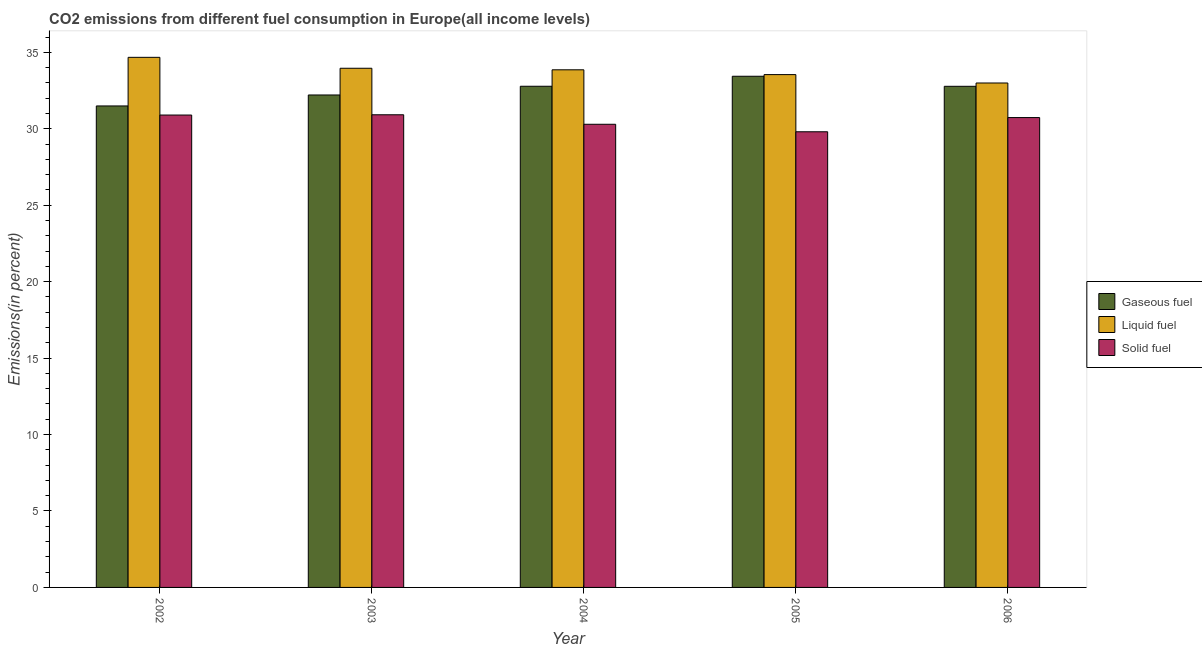How many bars are there on the 2nd tick from the left?
Provide a short and direct response. 3. What is the label of the 5th group of bars from the left?
Ensure brevity in your answer.  2006. In how many cases, is the number of bars for a given year not equal to the number of legend labels?
Your response must be concise. 0. What is the percentage of liquid fuel emission in 2003?
Your answer should be compact. 33.96. Across all years, what is the maximum percentage of solid fuel emission?
Offer a very short reply. 30.92. Across all years, what is the minimum percentage of liquid fuel emission?
Provide a short and direct response. 33. In which year was the percentage of liquid fuel emission maximum?
Your response must be concise. 2002. In which year was the percentage of gaseous fuel emission minimum?
Make the answer very short. 2002. What is the total percentage of solid fuel emission in the graph?
Ensure brevity in your answer.  152.65. What is the difference between the percentage of liquid fuel emission in 2002 and that in 2003?
Offer a terse response. 0.71. What is the difference between the percentage of liquid fuel emission in 2003 and the percentage of gaseous fuel emission in 2004?
Offer a terse response. 0.1. What is the average percentage of liquid fuel emission per year?
Provide a succinct answer. 33.81. In how many years, is the percentage of gaseous fuel emission greater than 31 %?
Offer a terse response. 5. What is the ratio of the percentage of gaseous fuel emission in 2002 to that in 2005?
Offer a terse response. 0.94. What is the difference between the highest and the second highest percentage of liquid fuel emission?
Your response must be concise. 0.71. What is the difference between the highest and the lowest percentage of gaseous fuel emission?
Ensure brevity in your answer.  1.94. Is the sum of the percentage of solid fuel emission in 2003 and 2006 greater than the maximum percentage of gaseous fuel emission across all years?
Keep it short and to the point. Yes. What does the 3rd bar from the left in 2005 represents?
Your response must be concise. Solid fuel. What does the 1st bar from the right in 2004 represents?
Ensure brevity in your answer.  Solid fuel. Are all the bars in the graph horizontal?
Ensure brevity in your answer.  No. What is the difference between two consecutive major ticks on the Y-axis?
Ensure brevity in your answer.  5. Where does the legend appear in the graph?
Offer a terse response. Center right. How are the legend labels stacked?
Offer a very short reply. Vertical. What is the title of the graph?
Give a very brief answer. CO2 emissions from different fuel consumption in Europe(all income levels). What is the label or title of the Y-axis?
Provide a succinct answer. Emissions(in percent). What is the Emissions(in percent) in Gaseous fuel in 2002?
Ensure brevity in your answer.  31.5. What is the Emissions(in percent) of Liquid fuel in 2002?
Keep it short and to the point. 34.68. What is the Emissions(in percent) in Solid fuel in 2002?
Your answer should be very brief. 30.9. What is the Emissions(in percent) in Gaseous fuel in 2003?
Your response must be concise. 32.21. What is the Emissions(in percent) in Liquid fuel in 2003?
Keep it short and to the point. 33.96. What is the Emissions(in percent) in Solid fuel in 2003?
Offer a very short reply. 30.92. What is the Emissions(in percent) in Gaseous fuel in 2004?
Give a very brief answer. 32.78. What is the Emissions(in percent) of Liquid fuel in 2004?
Your answer should be very brief. 33.86. What is the Emissions(in percent) in Solid fuel in 2004?
Offer a terse response. 30.3. What is the Emissions(in percent) in Gaseous fuel in 2005?
Offer a very short reply. 33.44. What is the Emissions(in percent) in Liquid fuel in 2005?
Offer a very short reply. 33.55. What is the Emissions(in percent) of Solid fuel in 2005?
Give a very brief answer. 29.81. What is the Emissions(in percent) in Gaseous fuel in 2006?
Your response must be concise. 32.78. What is the Emissions(in percent) in Liquid fuel in 2006?
Your answer should be compact. 33. What is the Emissions(in percent) of Solid fuel in 2006?
Provide a short and direct response. 30.73. Across all years, what is the maximum Emissions(in percent) of Gaseous fuel?
Offer a very short reply. 33.44. Across all years, what is the maximum Emissions(in percent) in Liquid fuel?
Provide a short and direct response. 34.68. Across all years, what is the maximum Emissions(in percent) of Solid fuel?
Your answer should be very brief. 30.92. Across all years, what is the minimum Emissions(in percent) of Gaseous fuel?
Keep it short and to the point. 31.5. Across all years, what is the minimum Emissions(in percent) in Liquid fuel?
Offer a terse response. 33. Across all years, what is the minimum Emissions(in percent) in Solid fuel?
Offer a very short reply. 29.81. What is the total Emissions(in percent) of Gaseous fuel in the graph?
Give a very brief answer. 162.71. What is the total Emissions(in percent) of Liquid fuel in the graph?
Offer a terse response. 169.04. What is the total Emissions(in percent) of Solid fuel in the graph?
Your answer should be compact. 152.65. What is the difference between the Emissions(in percent) in Gaseous fuel in 2002 and that in 2003?
Give a very brief answer. -0.72. What is the difference between the Emissions(in percent) of Liquid fuel in 2002 and that in 2003?
Give a very brief answer. 0.71. What is the difference between the Emissions(in percent) in Solid fuel in 2002 and that in 2003?
Offer a terse response. -0.02. What is the difference between the Emissions(in percent) of Gaseous fuel in 2002 and that in 2004?
Offer a terse response. -1.29. What is the difference between the Emissions(in percent) of Liquid fuel in 2002 and that in 2004?
Offer a terse response. 0.82. What is the difference between the Emissions(in percent) of Solid fuel in 2002 and that in 2004?
Your answer should be compact. 0.6. What is the difference between the Emissions(in percent) in Gaseous fuel in 2002 and that in 2005?
Make the answer very short. -1.94. What is the difference between the Emissions(in percent) in Liquid fuel in 2002 and that in 2005?
Make the answer very short. 1.13. What is the difference between the Emissions(in percent) of Solid fuel in 2002 and that in 2005?
Ensure brevity in your answer.  1.09. What is the difference between the Emissions(in percent) in Gaseous fuel in 2002 and that in 2006?
Provide a succinct answer. -1.28. What is the difference between the Emissions(in percent) in Liquid fuel in 2002 and that in 2006?
Provide a short and direct response. 1.68. What is the difference between the Emissions(in percent) of Solid fuel in 2002 and that in 2006?
Your answer should be very brief. 0.17. What is the difference between the Emissions(in percent) of Gaseous fuel in 2003 and that in 2004?
Keep it short and to the point. -0.57. What is the difference between the Emissions(in percent) of Liquid fuel in 2003 and that in 2004?
Ensure brevity in your answer.  0.1. What is the difference between the Emissions(in percent) in Solid fuel in 2003 and that in 2004?
Ensure brevity in your answer.  0.62. What is the difference between the Emissions(in percent) in Gaseous fuel in 2003 and that in 2005?
Make the answer very short. -1.22. What is the difference between the Emissions(in percent) in Liquid fuel in 2003 and that in 2005?
Your response must be concise. 0.41. What is the difference between the Emissions(in percent) of Solid fuel in 2003 and that in 2005?
Your answer should be very brief. 1.11. What is the difference between the Emissions(in percent) in Gaseous fuel in 2003 and that in 2006?
Your response must be concise. -0.57. What is the difference between the Emissions(in percent) of Liquid fuel in 2003 and that in 2006?
Give a very brief answer. 0.96. What is the difference between the Emissions(in percent) in Solid fuel in 2003 and that in 2006?
Offer a very short reply. 0.18. What is the difference between the Emissions(in percent) of Gaseous fuel in 2004 and that in 2005?
Ensure brevity in your answer.  -0.65. What is the difference between the Emissions(in percent) in Liquid fuel in 2004 and that in 2005?
Keep it short and to the point. 0.31. What is the difference between the Emissions(in percent) in Solid fuel in 2004 and that in 2005?
Ensure brevity in your answer.  0.49. What is the difference between the Emissions(in percent) in Gaseous fuel in 2004 and that in 2006?
Keep it short and to the point. 0. What is the difference between the Emissions(in percent) in Liquid fuel in 2004 and that in 2006?
Keep it short and to the point. 0.86. What is the difference between the Emissions(in percent) in Solid fuel in 2004 and that in 2006?
Your answer should be compact. -0.44. What is the difference between the Emissions(in percent) in Gaseous fuel in 2005 and that in 2006?
Your answer should be very brief. 0.66. What is the difference between the Emissions(in percent) in Liquid fuel in 2005 and that in 2006?
Your answer should be very brief. 0.55. What is the difference between the Emissions(in percent) in Solid fuel in 2005 and that in 2006?
Provide a succinct answer. -0.93. What is the difference between the Emissions(in percent) in Gaseous fuel in 2002 and the Emissions(in percent) in Liquid fuel in 2003?
Your response must be concise. -2.47. What is the difference between the Emissions(in percent) in Gaseous fuel in 2002 and the Emissions(in percent) in Solid fuel in 2003?
Your answer should be compact. 0.58. What is the difference between the Emissions(in percent) of Liquid fuel in 2002 and the Emissions(in percent) of Solid fuel in 2003?
Provide a succinct answer. 3.76. What is the difference between the Emissions(in percent) of Gaseous fuel in 2002 and the Emissions(in percent) of Liquid fuel in 2004?
Your response must be concise. -2.36. What is the difference between the Emissions(in percent) in Gaseous fuel in 2002 and the Emissions(in percent) in Solid fuel in 2004?
Ensure brevity in your answer.  1.2. What is the difference between the Emissions(in percent) in Liquid fuel in 2002 and the Emissions(in percent) in Solid fuel in 2004?
Offer a very short reply. 4.38. What is the difference between the Emissions(in percent) in Gaseous fuel in 2002 and the Emissions(in percent) in Liquid fuel in 2005?
Ensure brevity in your answer.  -2.05. What is the difference between the Emissions(in percent) of Gaseous fuel in 2002 and the Emissions(in percent) of Solid fuel in 2005?
Offer a terse response. 1.69. What is the difference between the Emissions(in percent) in Liquid fuel in 2002 and the Emissions(in percent) in Solid fuel in 2005?
Keep it short and to the point. 4.87. What is the difference between the Emissions(in percent) in Gaseous fuel in 2002 and the Emissions(in percent) in Liquid fuel in 2006?
Your answer should be very brief. -1.5. What is the difference between the Emissions(in percent) of Gaseous fuel in 2002 and the Emissions(in percent) of Solid fuel in 2006?
Keep it short and to the point. 0.76. What is the difference between the Emissions(in percent) of Liquid fuel in 2002 and the Emissions(in percent) of Solid fuel in 2006?
Your answer should be compact. 3.94. What is the difference between the Emissions(in percent) in Gaseous fuel in 2003 and the Emissions(in percent) in Liquid fuel in 2004?
Offer a terse response. -1.65. What is the difference between the Emissions(in percent) in Gaseous fuel in 2003 and the Emissions(in percent) in Solid fuel in 2004?
Your answer should be very brief. 1.92. What is the difference between the Emissions(in percent) of Liquid fuel in 2003 and the Emissions(in percent) of Solid fuel in 2004?
Make the answer very short. 3.66. What is the difference between the Emissions(in percent) in Gaseous fuel in 2003 and the Emissions(in percent) in Liquid fuel in 2005?
Keep it short and to the point. -1.33. What is the difference between the Emissions(in percent) in Gaseous fuel in 2003 and the Emissions(in percent) in Solid fuel in 2005?
Provide a short and direct response. 2.41. What is the difference between the Emissions(in percent) in Liquid fuel in 2003 and the Emissions(in percent) in Solid fuel in 2005?
Your response must be concise. 4.15. What is the difference between the Emissions(in percent) of Gaseous fuel in 2003 and the Emissions(in percent) of Liquid fuel in 2006?
Offer a very short reply. -0.78. What is the difference between the Emissions(in percent) of Gaseous fuel in 2003 and the Emissions(in percent) of Solid fuel in 2006?
Offer a very short reply. 1.48. What is the difference between the Emissions(in percent) in Liquid fuel in 2003 and the Emissions(in percent) in Solid fuel in 2006?
Offer a very short reply. 3.23. What is the difference between the Emissions(in percent) in Gaseous fuel in 2004 and the Emissions(in percent) in Liquid fuel in 2005?
Make the answer very short. -0.76. What is the difference between the Emissions(in percent) in Gaseous fuel in 2004 and the Emissions(in percent) in Solid fuel in 2005?
Provide a short and direct response. 2.98. What is the difference between the Emissions(in percent) in Liquid fuel in 2004 and the Emissions(in percent) in Solid fuel in 2005?
Give a very brief answer. 4.05. What is the difference between the Emissions(in percent) of Gaseous fuel in 2004 and the Emissions(in percent) of Liquid fuel in 2006?
Make the answer very short. -0.21. What is the difference between the Emissions(in percent) of Gaseous fuel in 2004 and the Emissions(in percent) of Solid fuel in 2006?
Provide a succinct answer. 2.05. What is the difference between the Emissions(in percent) of Liquid fuel in 2004 and the Emissions(in percent) of Solid fuel in 2006?
Your answer should be compact. 3.12. What is the difference between the Emissions(in percent) of Gaseous fuel in 2005 and the Emissions(in percent) of Liquid fuel in 2006?
Your answer should be compact. 0.44. What is the difference between the Emissions(in percent) in Gaseous fuel in 2005 and the Emissions(in percent) in Solid fuel in 2006?
Offer a very short reply. 2.7. What is the difference between the Emissions(in percent) of Liquid fuel in 2005 and the Emissions(in percent) of Solid fuel in 2006?
Your answer should be very brief. 2.81. What is the average Emissions(in percent) in Gaseous fuel per year?
Ensure brevity in your answer.  32.54. What is the average Emissions(in percent) in Liquid fuel per year?
Ensure brevity in your answer.  33.81. What is the average Emissions(in percent) in Solid fuel per year?
Offer a terse response. 30.53. In the year 2002, what is the difference between the Emissions(in percent) in Gaseous fuel and Emissions(in percent) in Liquid fuel?
Give a very brief answer. -3.18. In the year 2002, what is the difference between the Emissions(in percent) in Gaseous fuel and Emissions(in percent) in Solid fuel?
Your answer should be compact. 0.59. In the year 2002, what is the difference between the Emissions(in percent) of Liquid fuel and Emissions(in percent) of Solid fuel?
Ensure brevity in your answer.  3.77. In the year 2003, what is the difference between the Emissions(in percent) in Gaseous fuel and Emissions(in percent) in Liquid fuel?
Your answer should be very brief. -1.75. In the year 2003, what is the difference between the Emissions(in percent) in Gaseous fuel and Emissions(in percent) in Solid fuel?
Give a very brief answer. 1.29. In the year 2003, what is the difference between the Emissions(in percent) in Liquid fuel and Emissions(in percent) in Solid fuel?
Keep it short and to the point. 3.04. In the year 2004, what is the difference between the Emissions(in percent) in Gaseous fuel and Emissions(in percent) in Liquid fuel?
Provide a succinct answer. -1.08. In the year 2004, what is the difference between the Emissions(in percent) of Gaseous fuel and Emissions(in percent) of Solid fuel?
Make the answer very short. 2.49. In the year 2004, what is the difference between the Emissions(in percent) of Liquid fuel and Emissions(in percent) of Solid fuel?
Your answer should be very brief. 3.56. In the year 2005, what is the difference between the Emissions(in percent) in Gaseous fuel and Emissions(in percent) in Liquid fuel?
Your answer should be very brief. -0.11. In the year 2005, what is the difference between the Emissions(in percent) of Gaseous fuel and Emissions(in percent) of Solid fuel?
Make the answer very short. 3.63. In the year 2005, what is the difference between the Emissions(in percent) in Liquid fuel and Emissions(in percent) in Solid fuel?
Give a very brief answer. 3.74. In the year 2006, what is the difference between the Emissions(in percent) in Gaseous fuel and Emissions(in percent) in Liquid fuel?
Give a very brief answer. -0.22. In the year 2006, what is the difference between the Emissions(in percent) of Gaseous fuel and Emissions(in percent) of Solid fuel?
Keep it short and to the point. 2.05. In the year 2006, what is the difference between the Emissions(in percent) in Liquid fuel and Emissions(in percent) in Solid fuel?
Provide a succinct answer. 2.26. What is the ratio of the Emissions(in percent) in Gaseous fuel in 2002 to that in 2003?
Your answer should be very brief. 0.98. What is the ratio of the Emissions(in percent) in Gaseous fuel in 2002 to that in 2004?
Offer a very short reply. 0.96. What is the ratio of the Emissions(in percent) of Liquid fuel in 2002 to that in 2004?
Your answer should be very brief. 1.02. What is the ratio of the Emissions(in percent) of Solid fuel in 2002 to that in 2004?
Your answer should be compact. 1.02. What is the ratio of the Emissions(in percent) of Gaseous fuel in 2002 to that in 2005?
Give a very brief answer. 0.94. What is the ratio of the Emissions(in percent) in Liquid fuel in 2002 to that in 2005?
Offer a very short reply. 1.03. What is the ratio of the Emissions(in percent) of Solid fuel in 2002 to that in 2005?
Keep it short and to the point. 1.04. What is the ratio of the Emissions(in percent) in Gaseous fuel in 2002 to that in 2006?
Provide a succinct answer. 0.96. What is the ratio of the Emissions(in percent) in Liquid fuel in 2002 to that in 2006?
Give a very brief answer. 1.05. What is the ratio of the Emissions(in percent) in Solid fuel in 2002 to that in 2006?
Ensure brevity in your answer.  1.01. What is the ratio of the Emissions(in percent) in Gaseous fuel in 2003 to that in 2004?
Ensure brevity in your answer.  0.98. What is the ratio of the Emissions(in percent) in Liquid fuel in 2003 to that in 2004?
Keep it short and to the point. 1. What is the ratio of the Emissions(in percent) of Solid fuel in 2003 to that in 2004?
Make the answer very short. 1.02. What is the ratio of the Emissions(in percent) of Gaseous fuel in 2003 to that in 2005?
Offer a terse response. 0.96. What is the ratio of the Emissions(in percent) in Liquid fuel in 2003 to that in 2005?
Offer a terse response. 1.01. What is the ratio of the Emissions(in percent) of Solid fuel in 2003 to that in 2005?
Your response must be concise. 1.04. What is the ratio of the Emissions(in percent) in Gaseous fuel in 2003 to that in 2006?
Your response must be concise. 0.98. What is the ratio of the Emissions(in percent) in Liquid fuel in 2003 to that in 2006?
Your answer should be compact. 1.03. What is the ratio of the Emissions(in percent) in Solid fuel in 2003 to that in 2006?
Your response must be concise. 1.01. What is the ratio of the Emissions(in percent) in Gaseous fuel in 2004 to that in 2005?
Offer a very short reply. 0.98. What is the ratio of the Emissions(in percent) in Liquid fuel in 2004 to that in 2005?
Your answer should be compact. 1.01. What is the ratio of the Emissions(in percent) of Solid fuel in 2004 to that in 2005?
Keep it short and to the point. 1.02. What is the ratio of the Emissions(in percent) of Gaseous fuel in 2004 to that in 2006?
Your answer should be compact. 1. What is the ratio of the Emissions(in percent) in Liquid fuel in 2004 to that in 2006?
Provide a succinct answer. 1.03. What is the ratio of the Emissions(in percent) of Solid fuel in 2004 to that in 2006?
Keep it short and to the point. 0.99. What is the ratio of the Emissions(in percent) in Liquid fuel in 2005 to that in 2006?
Offer a very short reply. 1.02. What is the ratio of the Emissions(in percent) in Solid fuel in 2005 to that in 2006?
Offer a very short reply. 0.97. What is the difference between the highest and the second highest Emissions(in percent) in Gaseous fuel?
Offer a terse response. 0.65. What is the difference between the highest and the second highest Emissions(in percent) in Liquid fuel?
Your answer should be very brief. 0.71. What is the difference between the highest and the second highest Emissions(in percent) in Solid fuel?
Keep it short and to the point. 0.02. What is the difference between the highest and the lowest Emissions(in percent) in Gaseous fuel?
Keep it short and to the point. 1.94. What is the difference between the highest and the lowest Emissions(in percent) in Liquid fuel?
Make the answer very short. 1.68. What is the difference between the highest and the lowest Emissions(in percent) of Solid fuel?
Keep it short and to the point. 1.11. 